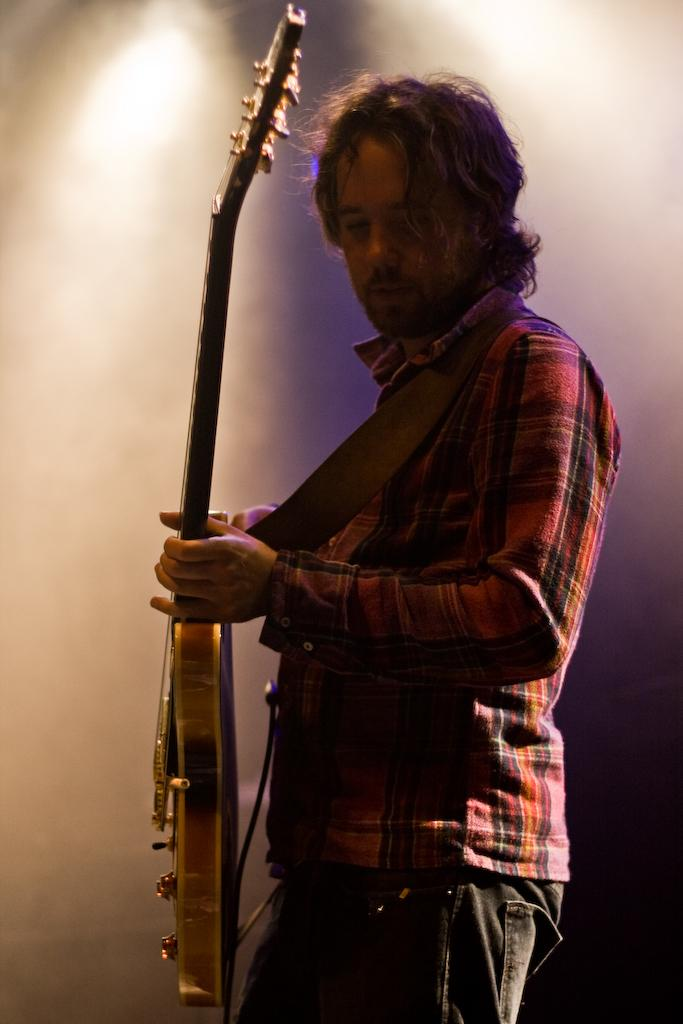Who is the main subject in the image? There is a man in the picture. What is the man doing in the image? The man is standing in the image. What object is the man holding in his hands? The man is holding a guitar in his hands. Can you describe the background of the image? The background of the image is blurry. What type of mine is visible in the background of the image? There is no mine present in the image; the background is blurry. Is the man sitting on a chair in the image? The provided facts do not mention a chair, and the man is standing in the image. What can be seen in the aftermath of the event in the image? There is no event mentioned in the image, and the man is simply standing with a guitar. 